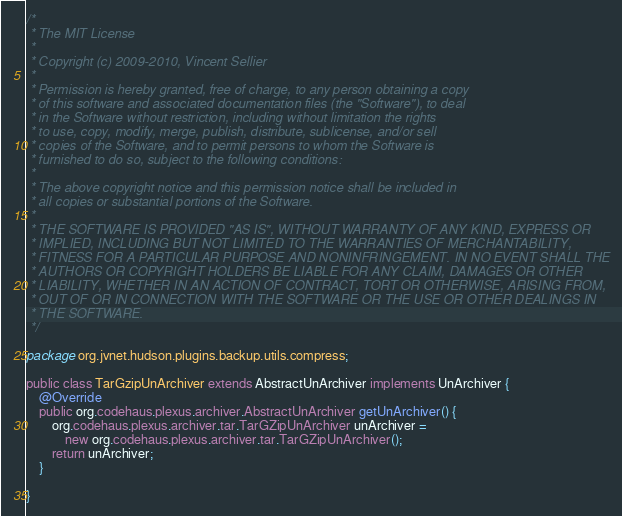Convert code to text. <code><loc_0><loc_0><loc_500><loc_500><_Java_>/*
 * The MIT License
 *
 * Copyright (c) 2009-2010, Vincent Sellier
 *
 * Permission is hereby granted, free of charge, to any person obtaining a copy
 * of this software and associated documentation files (the "Software"), to deal
 * in the Software without restriction, including without limitation the rights
 * to use, copy, modify, merge, publish, distribute, sublicense, and/or sell
 * copies of the Software, and to permit persons to whom the Software is
 * furnished to do so, subject to the following conditions:
 *
 * The above copyright notice and this permission notice shall be included in
 * all copies or substantial portions of the Software.
 *
 * THE SOFTWARE IS PROVIDED "AS IS", WITHOUT WARRANTY OF ANY KIND, EXPRESS OR
 * IMPLIED, INCLUDING BUT NOT LIMITED TO THE WARRANTIES OF MERCHANTABILITY,
 * FITNESS FOR A PARTICULAR PURPOSE AND NONINFRINGEMENT. IN NO EVENT SHALL THE
 * AUTHORS OR COPYRIGHT HOLDERS BE LIABLE FOR ANY CLAIM, DAMAGES OR OTHER
 * LIABILITY, WHETHER IN AN ACTION OF CONTRACT, TORT OR OTHERWISE, ARISING FROM,
 * OUT OF OR IN CONNECTION WITH THE SOFTWARE OR THE USE OR OTHER DEALINGS IN
 * THE SOFTWARE.
 */

package org.jvnet.hudson.plugins.backup.utils.compress;

public class TarGzipUnArchiver extends AbstractUnArchiver implements UnArchiver {
	@Override
	public org.codehaus.plexus.archiver.AbstractUnArchiver getUnArchiver() {
		org.codehaus.plexus.archiver.tar.TarGZipUnArchiver unArchiver =
			new org.codehaus.plexus.archiver.tar.TarGZipUnArchiver();
		return unArchiver;
	}

}
</code> 